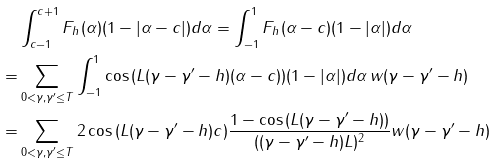<formula> <loc_0><loc_0><loc_500><loc_500>& \int _ { c - 1 } ^ { c + 1 } F _ { h } ( \alpha ) ( 1 - | \alpha - c | ) d \alpha = \int _ { - 1 } ^ { 1 } F _ { h } ( \alpha - c ) ( 1 - | \alpha | ) d \alpha \\ = & \sum _ { 0 < \gamma , \gamma ^ { \prime } \leq T } \int _ { - 1 } ^ { 1 } \cos { ( L ( \gamma - \gamma ^ { \prime } - h ) ( \alpha - c ) ) } ( 1 - | \alpha | ) d \alpha \, w ( \gamma - \gamma ^ { \prime } - h ) \\ = & \sum _ { 0 < \gamma , \gamma ^ { \prime } \leq T } 2 \cos { ( L ( \gamma - \gamma ^ { \prime } - h ) c ) } \frac { 1 - \cos { ( L ( \gamma - \gamma ^ { \prime } - h ) ) } } { ( ( \gamma - \gamma ^ { \prime } - h ) L ) ^ { 2 } } w ( \gamma - \gamma ^ { \prime } - h )</formula> 